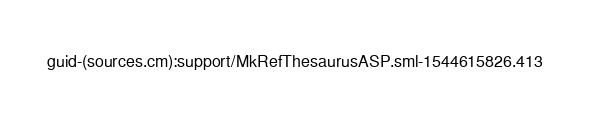Convert code to text. <code><loc_0><loc_0><loc_500><loc_500><_SML_>guid-(sources.cm):support/MkRefThesaurusASP.sml-1544615826.413
</code> 